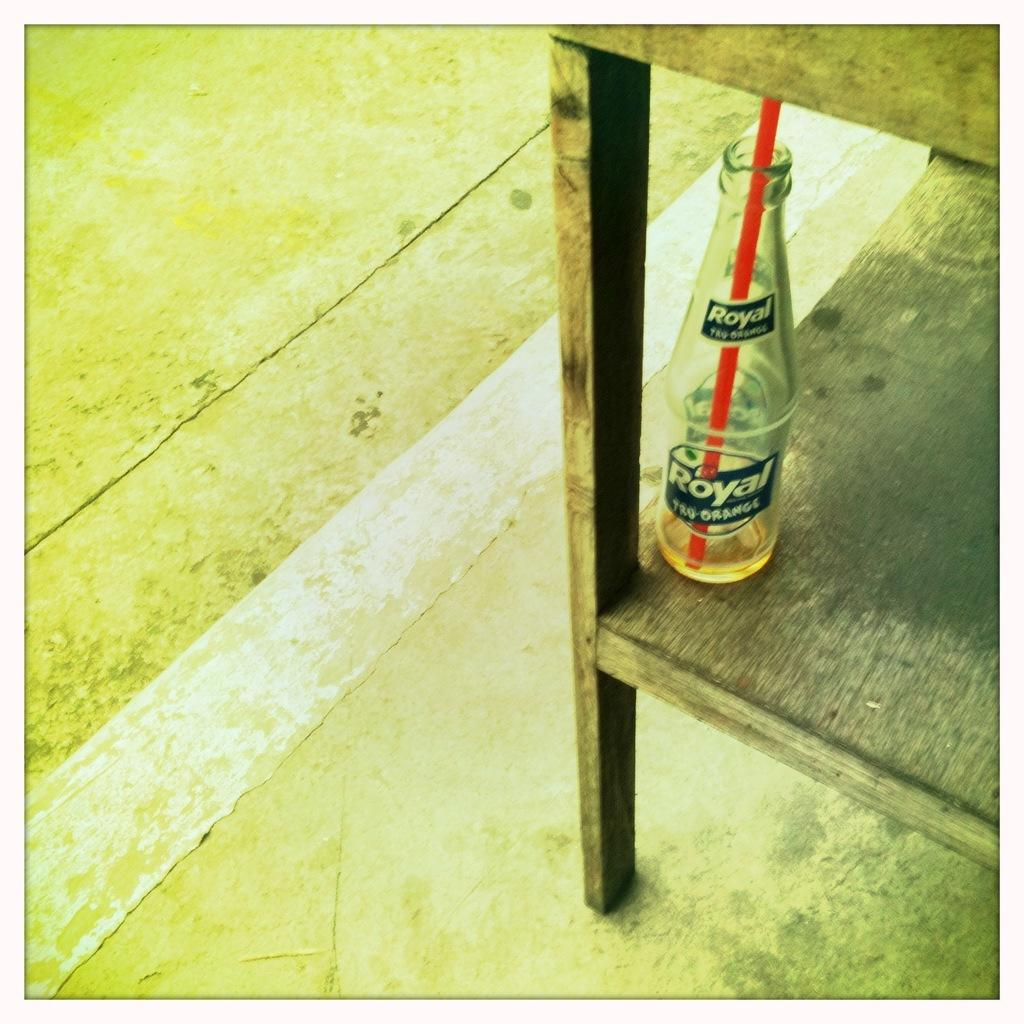Provide a one-sentence caption for the provided image. The flavor of the Royal bottle is Tru-orange. 